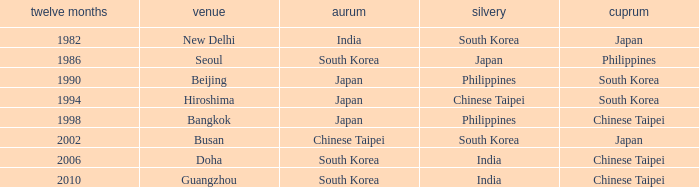Which Location has a Silver of japan? Seoul. 